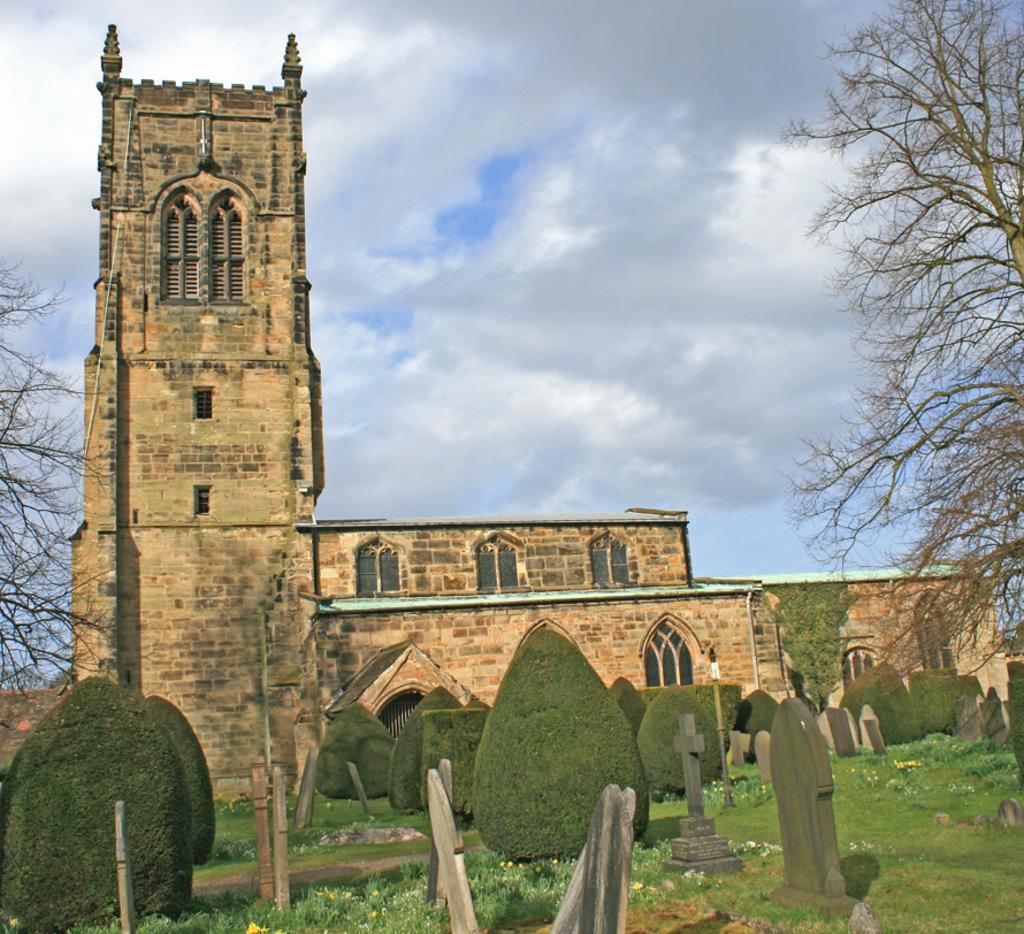In one or two sentences, can you explain what this image depicts? In this image we can see a building. There is a cloudy sky in the image. There are many trees and plants in the image. There are many flowers to the plants. There is a grassy land in the image. 